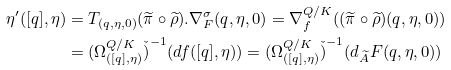Convert formula to latex. <formula><loc_0><loc_0><loc_500><loc_500>\eta ^ { \prime } ( [ q ] , \eta ) & = T _ { ( q , \eta , 0 ) } ( \widetilde { \pi } \circ \widetilde { \rho } ) . \nabla _ { F } ^ { \sigma } ( q , \eta , 0 ) = \nabla _ { f } ^ { Q / K } ( ( \widetilde { \pi } \circ \widetilde { \rho } ) ( q , \eta , 0 ) ) \\ & = ( \Omega _ { ( [ q ] , \eta ) } ^ { Q / K } \check { ) } ^ { - 1 } ( d f ( [ q ] , \eta ) ) = ( \Omega _ { ( [ q ] , \eta ) } ^ { Q / K } \check { ) } ^ { - 1 } ( d _ { \widetilde { A } } F ( q , \eta , 0 ) )</formula> 